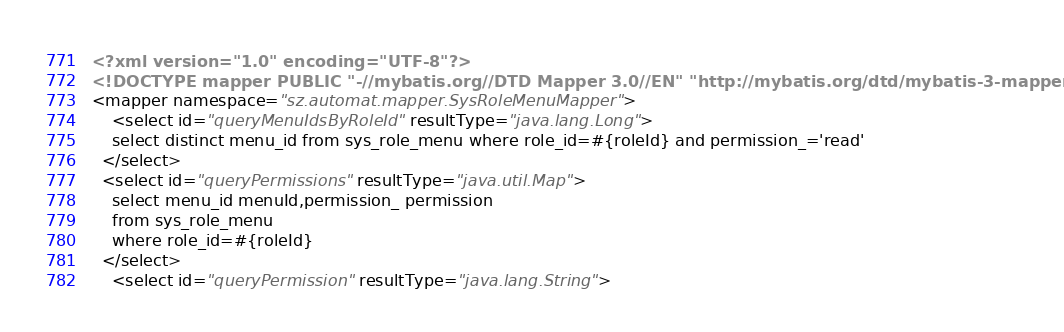Convert code to text. <code><loc_0><loc_0><loc_500><loc_500><_XML_><?xml version="1.0" encoding="UTF-8"?>
<!DOCTYPE mapper PUBLIC "-//mybatis.org//DTD Mapper 3.0//EN" "http://mybatis.org/dtd/mybatis-3-mapper.dtd">
<mapper namespace="sz.automat.mapper.SysRoleMenuMapper">
	<select id="queryMenuIdsByRoleId" resultType="java.lang.Long">
  	select distinct menu_id from sys_role_menu where role_id=#{roleId} and permission_='read'
  </select>
  <select id="queryPermissions" resultType="java.util.Map">
  	select menu_id menuId,permission_ permission
  	from sys_role_menu
	where role_id=#{roleId}
  </select>
	<select id="queryPermission" resultType="java.lang.String"></code> 